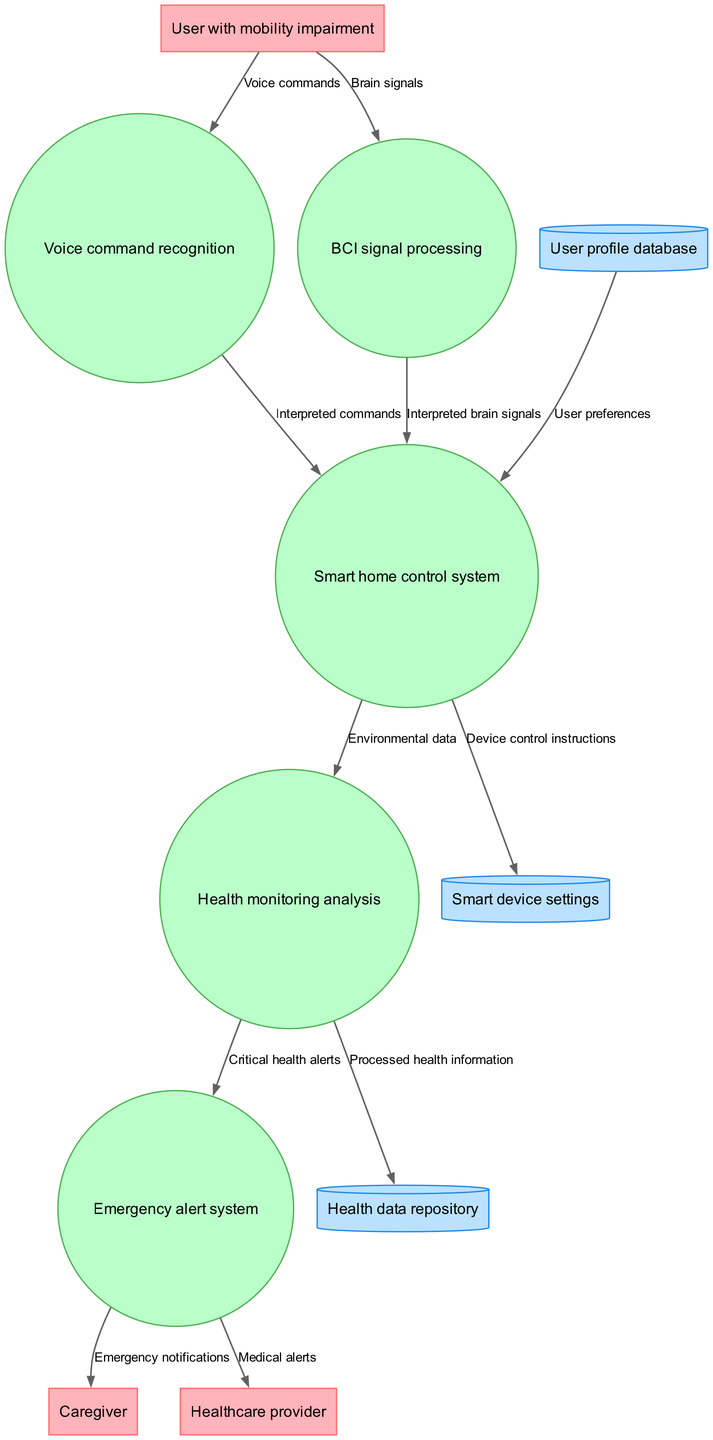What are the external entities in this diagram? The external entities listed in the diagram include "User with mobility impairment," "Caregiver," and "Healthcare provider." These are represented by rectangles in the Data Flow Diagram.
Answer: User with mobility impairment, Caregiver, Healthcare provider How many processes are present in the diagram? There are five processes in the diagram: "Voice command recognition," "BCI signal processing," "Smart home control system," "Health monitoring analysis," and "Emergency alert system." Each process is represented by circles.
Answer: Five What type of data flow is represented from the "User with mobility impairment" to "Voice command recognition"? The data flow from "User with mobility impairment" to "Voice command recognition" is labeled as "Voice commands." This indicates the information being transferred, which is the user's voice input for commands.
Answer: Voice commands Which process sends data to the "Emergency alert system"? The process that sends data to the "Emergency alert system" is "Health monitoring analysis." It forwards "Critical health alerts," which indicates the information being transitioned to ensure proper emergency responses.
Answer: Health monitoring analysis What is the role of the "Smart home control system" in relation to user preferences? The "Smart home control system" receives "User preferences" from the "User profile database," integrating this information to tailor the smart home environment according to the needs and preferences of the user.
Answer: User preferences What data flows into the "Health data repository"? The data that flows into the "Health data repository" comes from the "Health monitoring analysis," and it is labeled as "Processed health information." This means it archives the analyzed health data for further reference.
Answer: Processed health information Who receives notifications from the "Emergency alert system"? Notifications from the "Emergency alert system" are sent to both the "Caregiver" and the "Healthcare provider," indicating that any critical alerts generated will be communicated to these external entities for immediate attention.
Answer: Caregiver, Healthcare provider What is the relationship between "BCI signal processing" and "Smart home control system"? The "BCI signal processing" sends "Interpreted brain signals" to the "Smart home control system," which utilizes this processed information to execute relevant commands, providing a bridge between brain activity and smart home operations.
Answer: Interpreted brain signals How does the "Voice command recognition" process interact with the "Smart device settings"? The "Voice command recognition" process interacts with the "Smart home control system," forwarding "Interpreted commands," which are then sent as "Device control instructions" to "Smart device settings," allowing for control of various devices in the smart home.
Answer: Device control instructions 